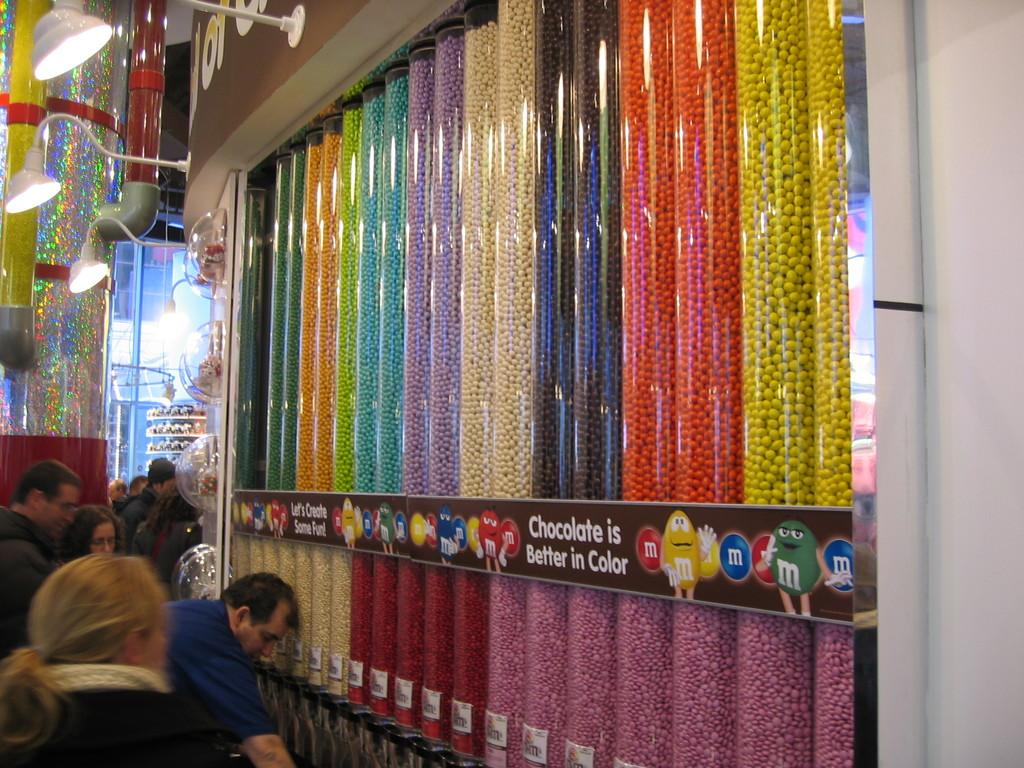<image>
Give a short and clear explanation of the subsequent image. Long tubes of M&M's with the saying Chocolate is Better in Color across them. 